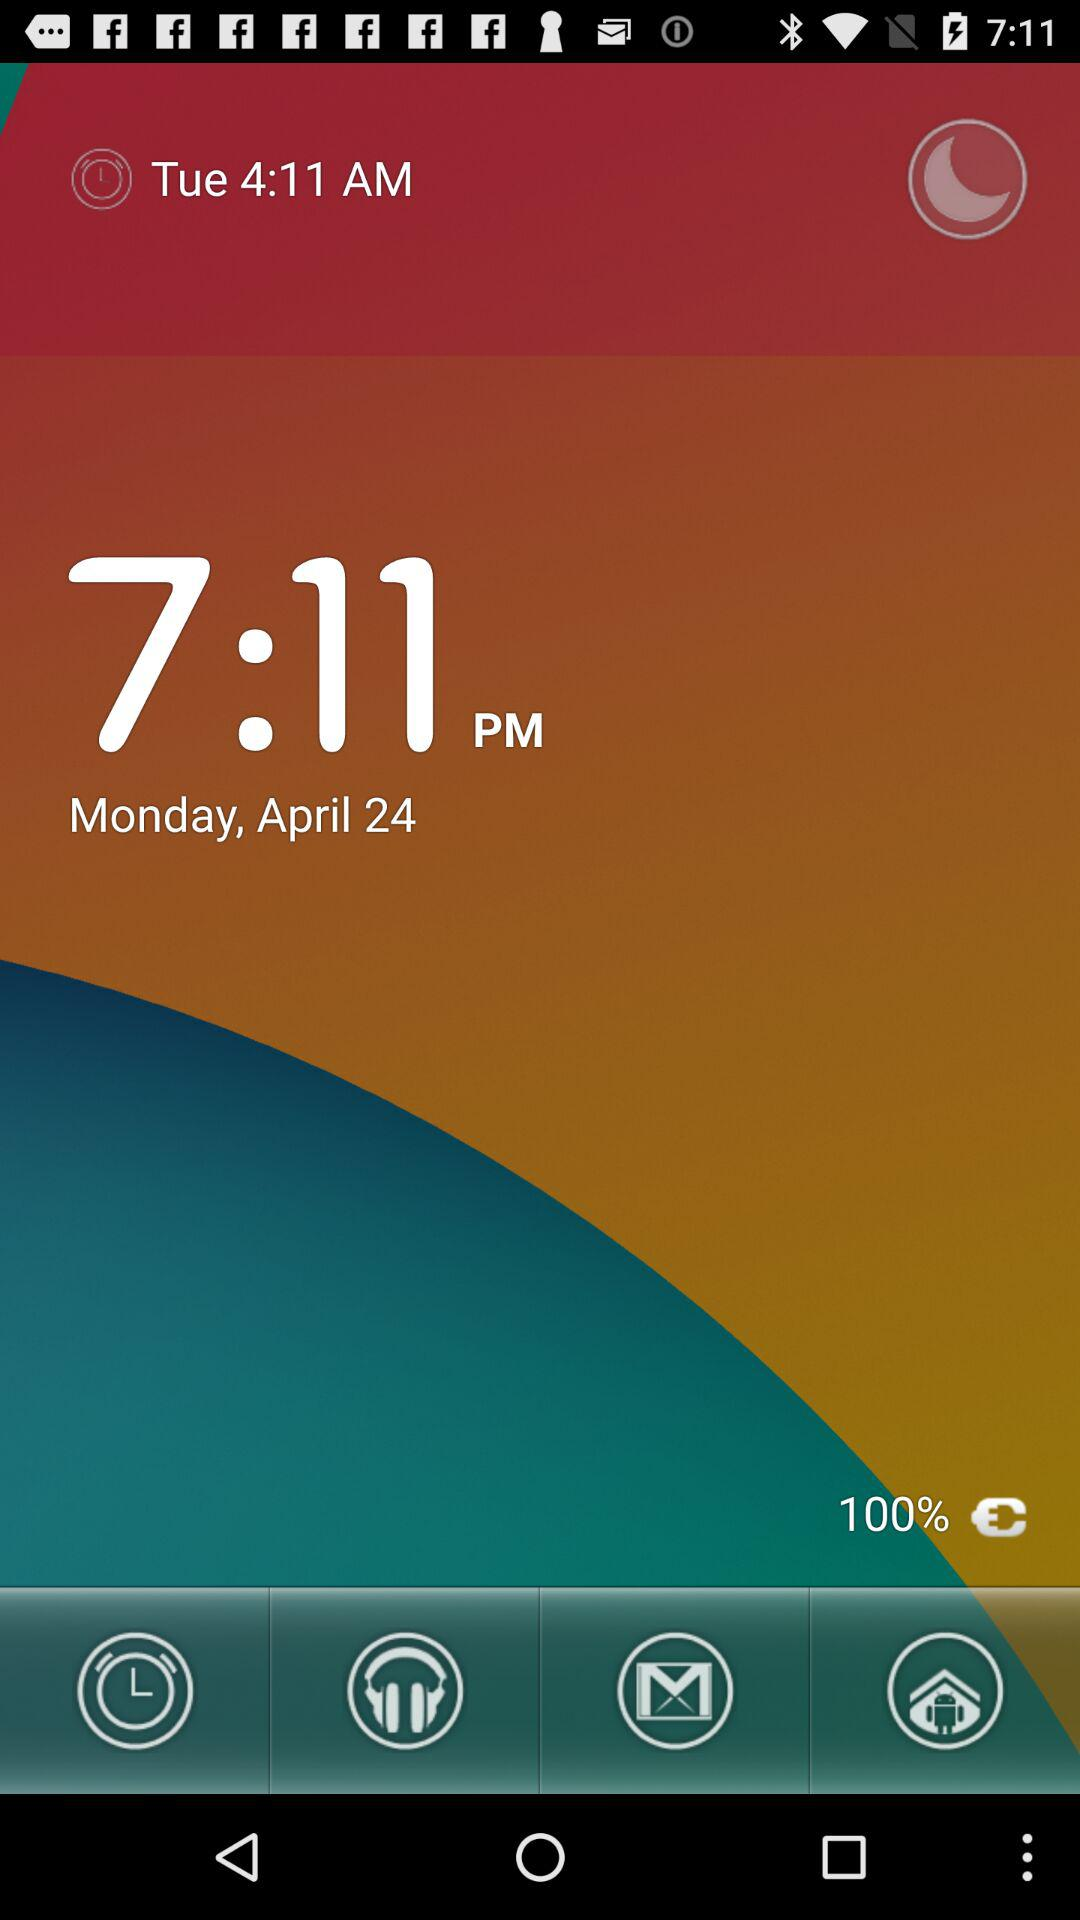What is the current date and time? The current date is Monday, April 24 and the time is 7:11 p.m. 